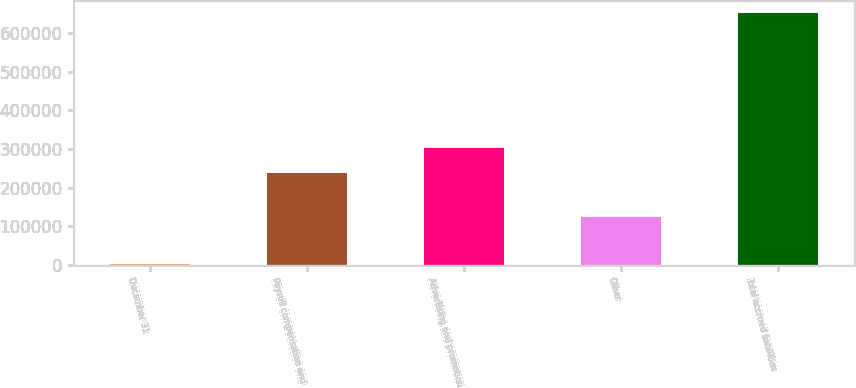Convert chart to OTSL. <chart><loc_0><loc_0><loc_500><loc_500><bar_chart><fcel>December 31<fcel>Payroll compensation and<fcel>Advertising and promotion<fcel>Other<fcel>Total accrued liabilities<nl><fcel>2012<fcel>236598<fcel>301487<fcel>125087<fcel>650906<nl></chart> 